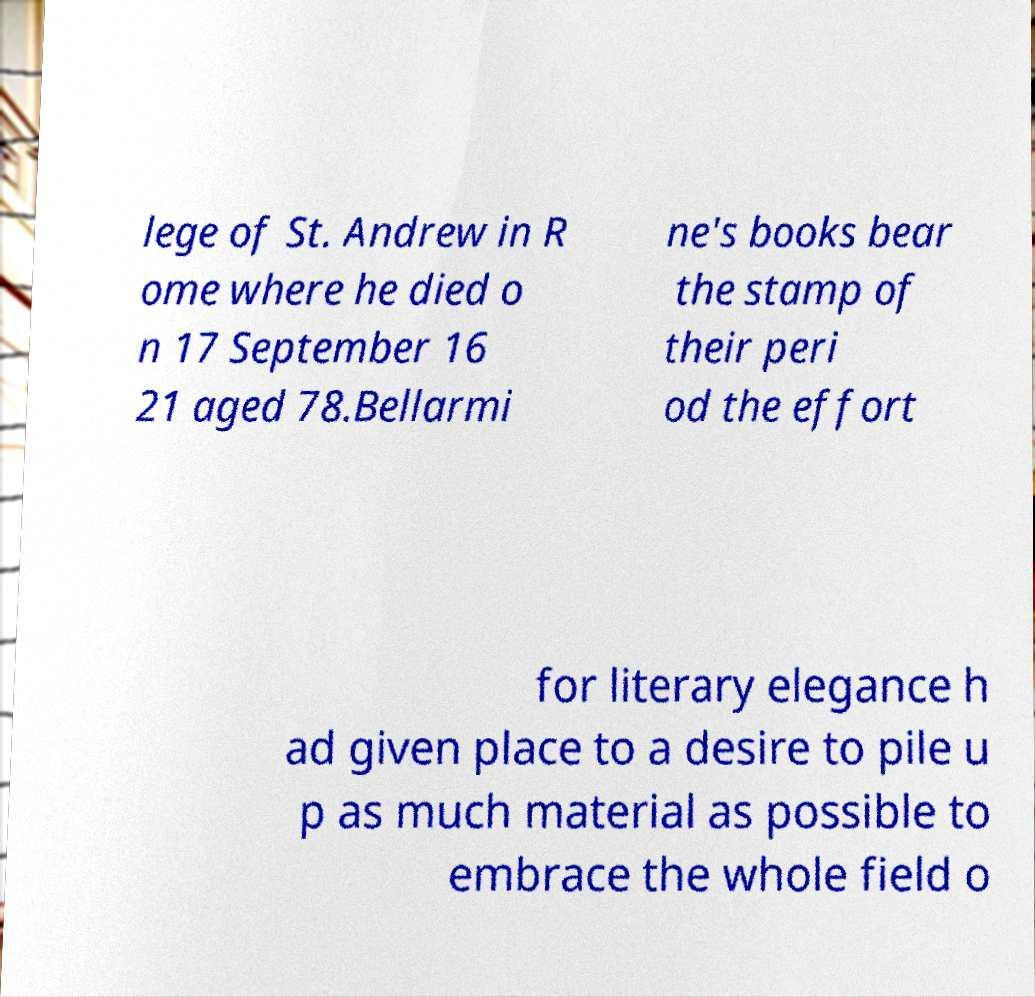Could you extract and type out the text from this image? lege of St. Andrew in R ome where he died o n 17 September 16 21 aged 78.Bellarmi ne's books bear the stamp of their peri od the effort for literary elegance h ad given place to a desire to pile u p as much material as possible to embrace the whole field o 